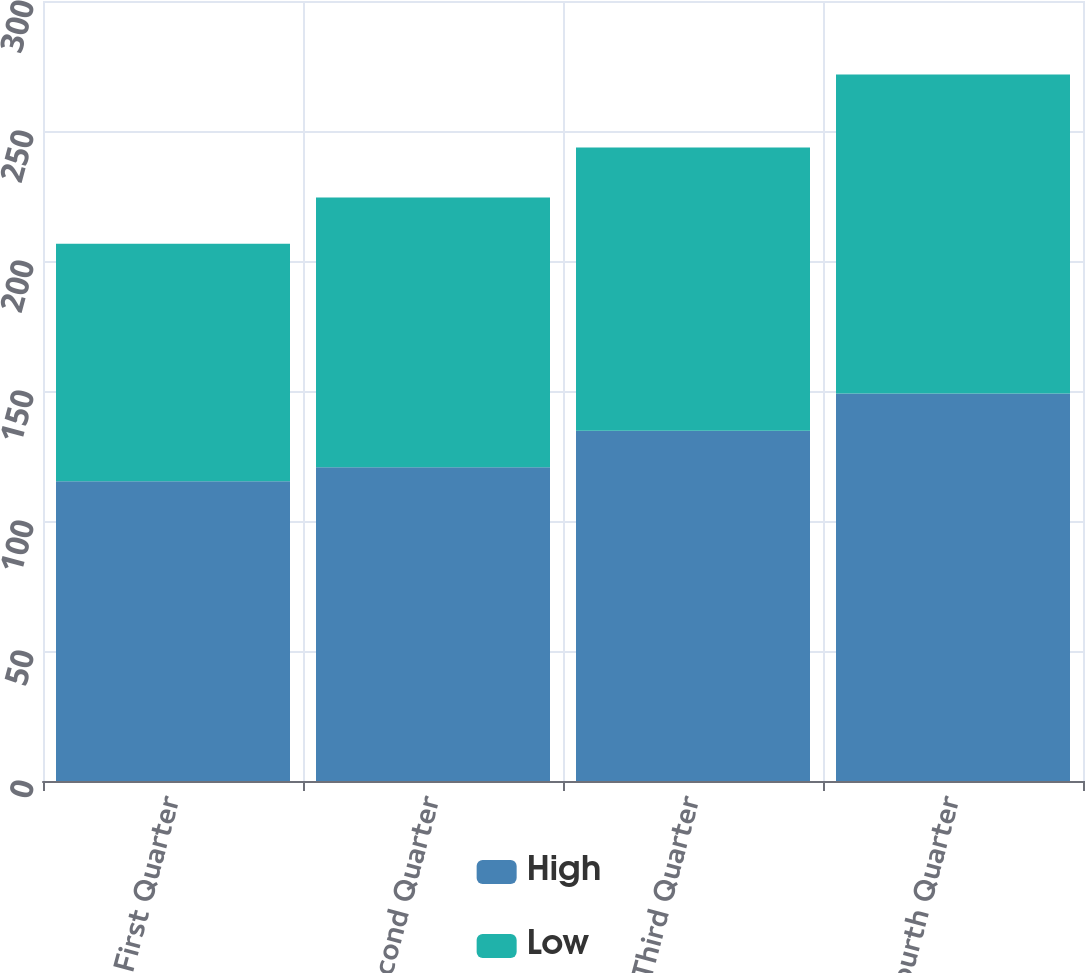Convert chart. <chart><loc_0><loc_0><loc_500><loc_500><stacked_bar_chart><ecel><fcel>First Quarter<fcel>Second Quarter<fcel>Third Quarter<fcel>Fourth Quarter<nl><fcel>High<fcel>115.32<fcel>120.7<fcel>134.75<fcel>149.01<nl><fcel>Low<fcel>91.3<fcel>103.74<fcel>108.89<fcel>122.74<nl></chart> 